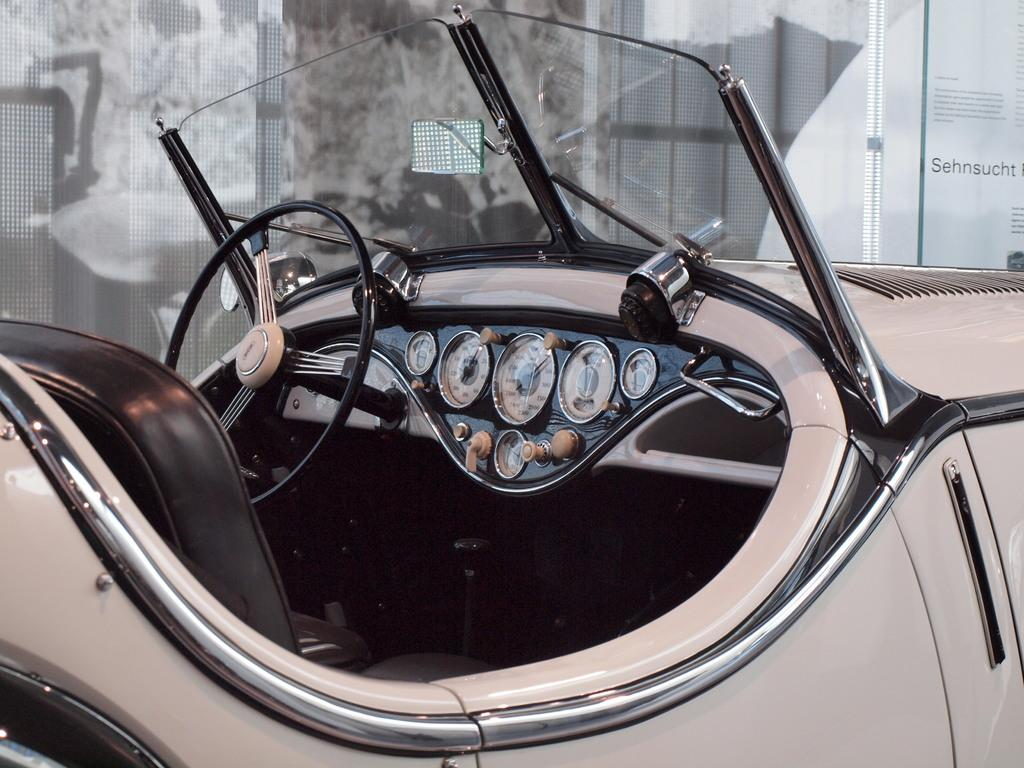What type of vehicle is shown in the image? The image shows a side view of a vehicle. What can be seen inside the vehicle? The vehicle has a steering wheel and speed meters. Are there any other elements in the vehicle that are not specified? Yes, there are other unspecified elements in the vehicle. What is present on the right side of the image? There is text on the right side of the image. Can you see any clouds inside the vehicle in the image? No, there are no clouds visible inside the vehicle in the image. Is there a pet sitting on the driver's lap in the image? There is no pet visible in the image. 